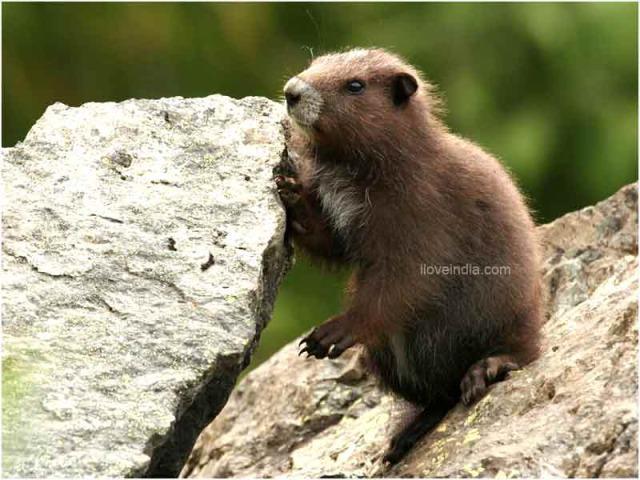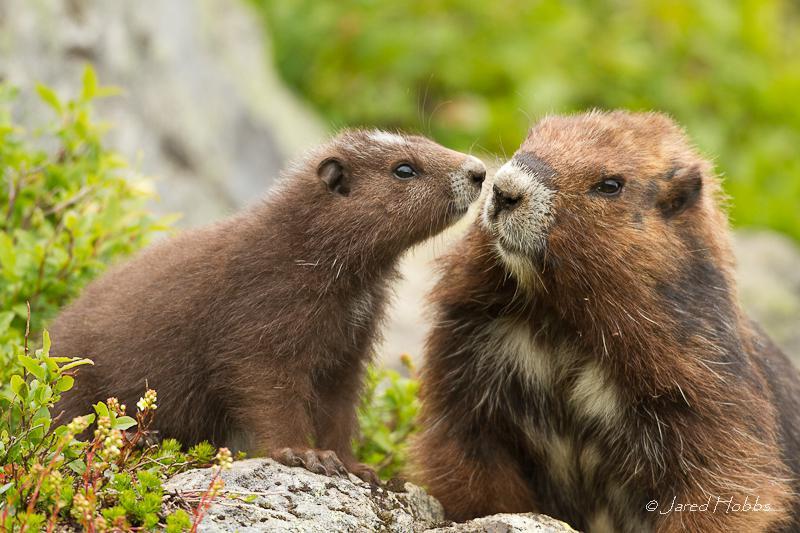The first image is the image on the left, the second image is the image on the right. Considering the images on both sides, is "There are a total of 3 young capybara." valid? Answer yes or no. Yes. The first image is the image on the left, the second image is the image on the right. Analyze the images presented: Is the assertion "there are 3 gophers on rocky surfaces in the image pair" valid? Answer yes or no. Yes. 